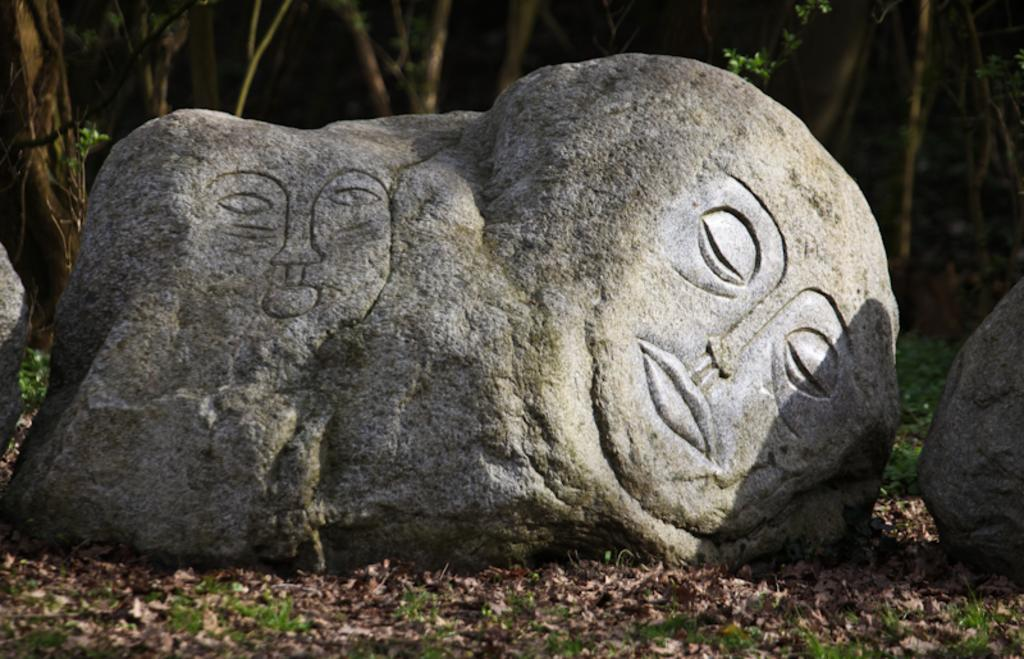What is the main subject in the image? There is a sculpture in the image. What else can be seen in the image besides the sculpture? There are two stones, dry leaves on the ground, and grass on the ground in the image. What is visible in the background of the image? There are trees in the background of the image. What type of pancake is being served on the grass in the image? There is no pancake present in the image; it features a sculpture, stones, dry leaves, grass, and trees. 